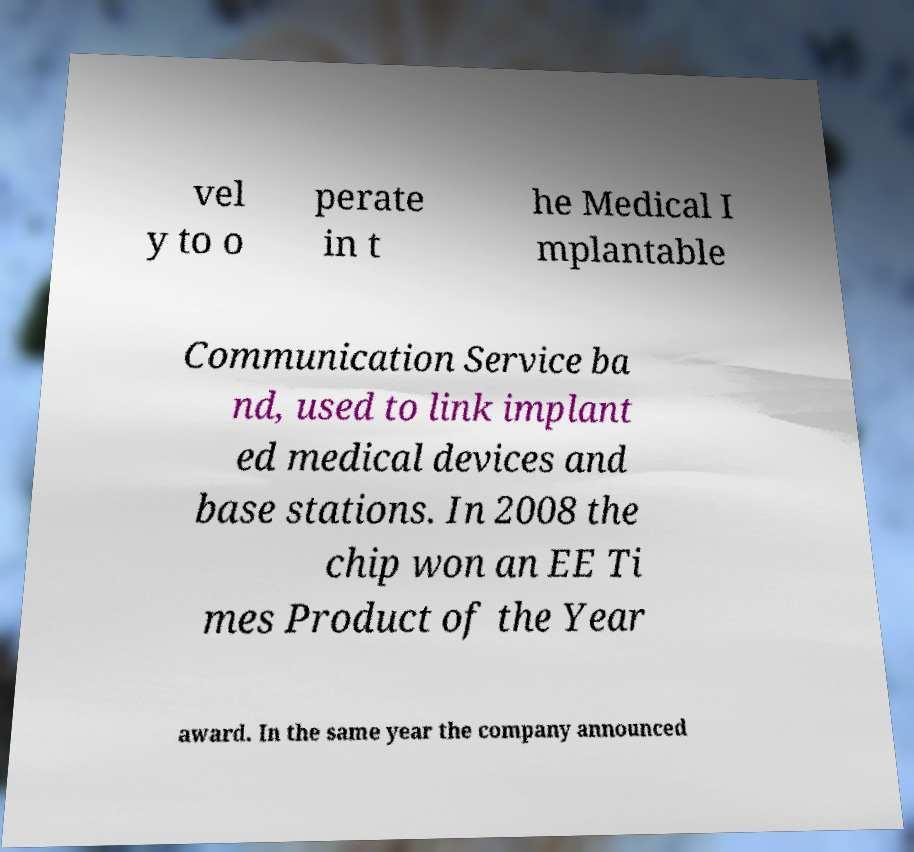What messages or text are displayed in this image? I need them in a readable, typed format. vel y to o perate in t he Medical I mplantable Communication Service ba nd, used to link implant ed medical devices and base stations. In 2008 the chip won an EE Ti mes Product of the Year award. In the same year the company announced 